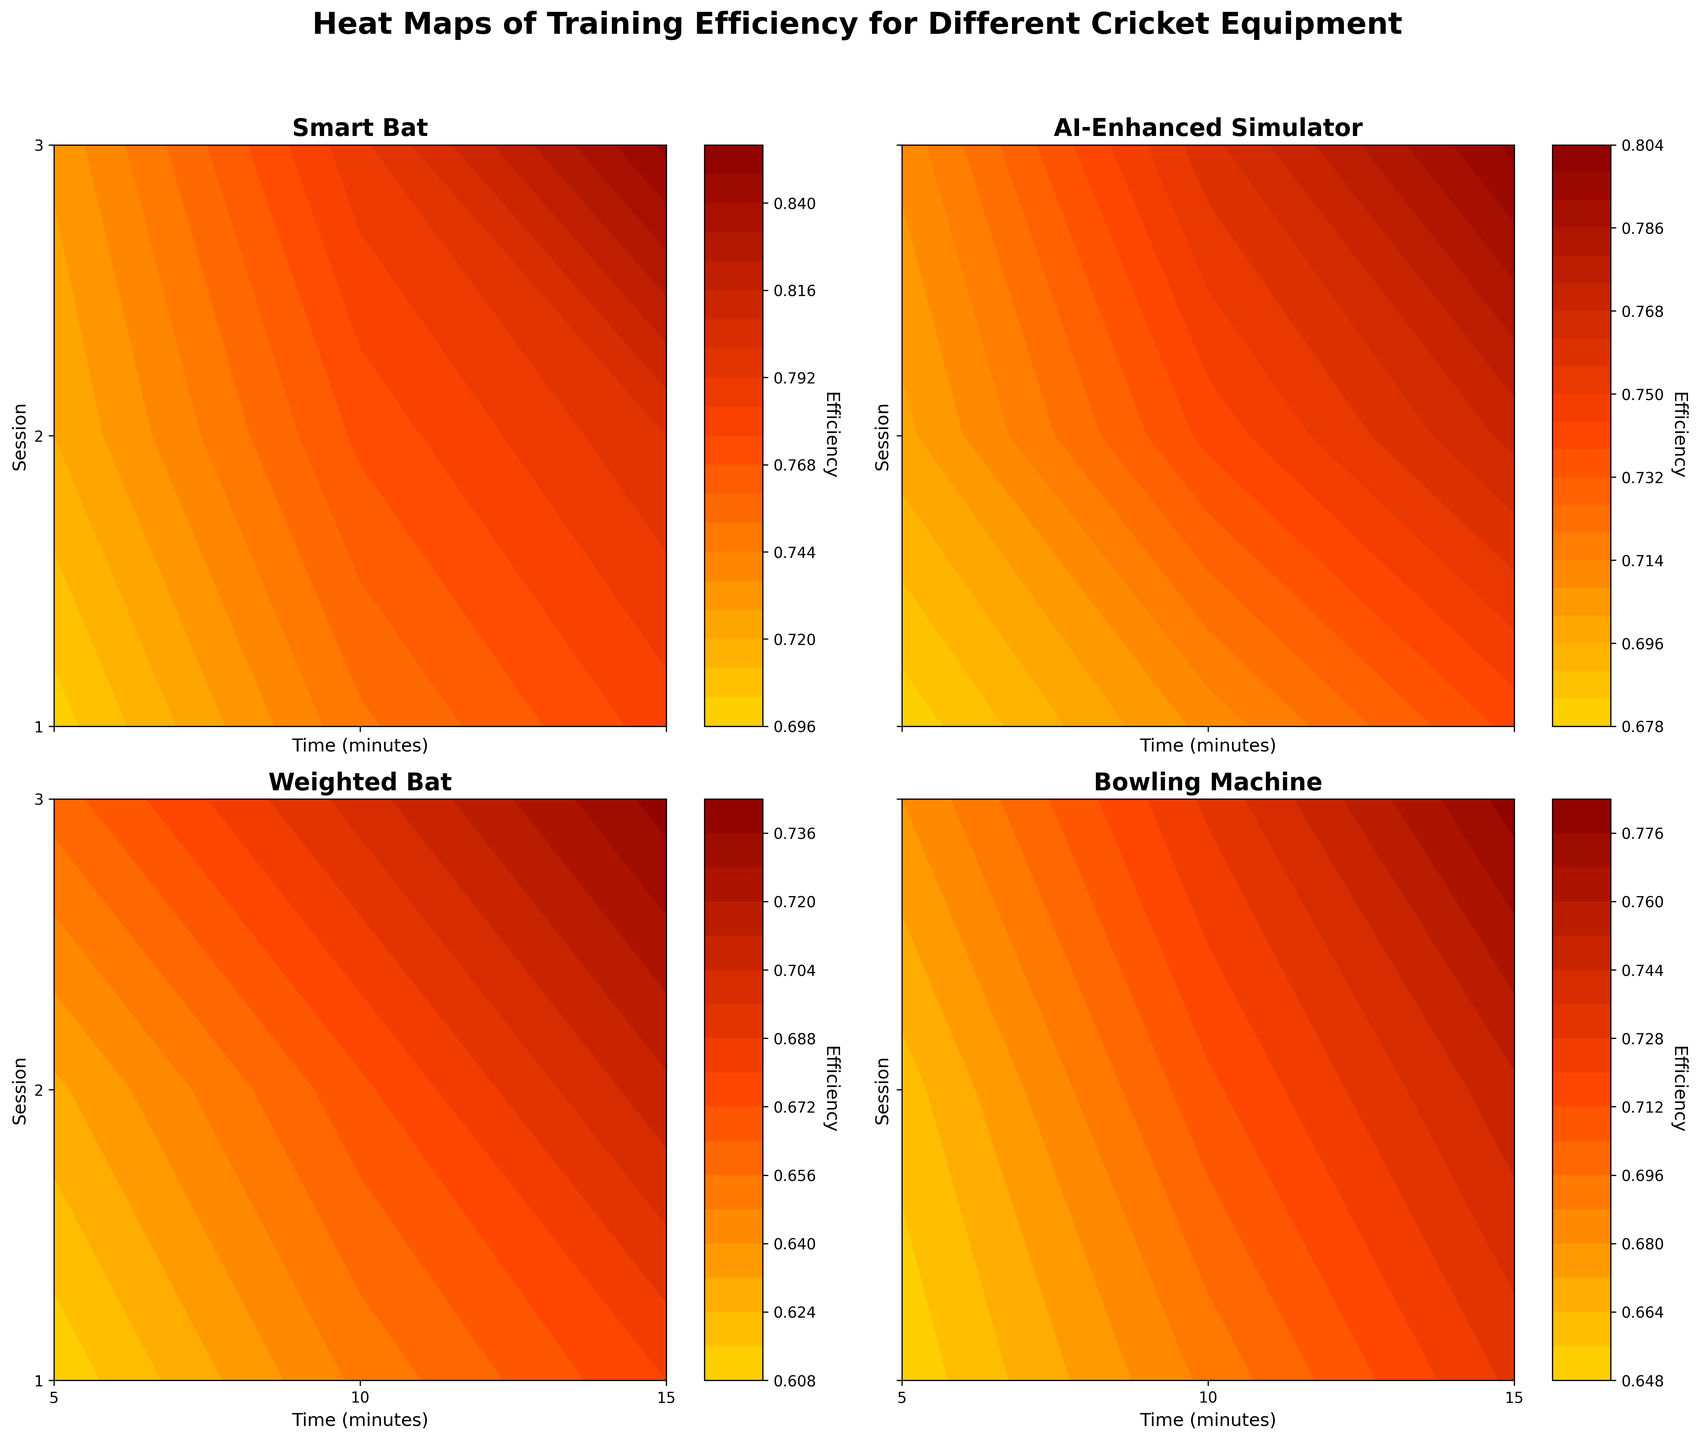What is the title of the figure? The figure's title is typically shown at the top of the plot. By looking at the rendered image, we can see the main title.
Answer: 'Heat Maps of Training Efficiency for Different Cricket Equipment' Which equipment appears to have the highest efficiency in the third training session? To determine this, we need to look at the contour plots for the third session across different equipment and see which has the darkest color (highest efficiency) in the third session. The darkest and most concentrated color areas indicate higher efficiency.
Answer: 'Smart Bat' What is the general trend of efficiency over time for the Bowling Machine? Observing the contour plot for the Bowling Machine from left to right (5 to 15 minutes), we see that the color gradually shifts to a darker tone as time increases, indicating that efficiency generally improves over time.
Answer: 'Efficiency increases over time' At 10 minutes, which equipment shows the lowest efficiency in the first session? By examining the contour plots for all equipment at the 10-minute mark during the first session, we compare the color intensity. The lighter the color, the lower the efficiency. Weighted Bat shows the lightest color at 10 minutes in the first session.
Answer: 'Weighted Bat' How does the efficiency progression compare between Smart Bat and AI-Enhanced Simulator in the second session? For a detailed comparison, look at the second session's contour plots for both Smart Bat and AI-Enhanced Simulator. Track the changes in color from 5 to 15 minutes. Both equipment show a progression to higher efficiency, but the Smart Bat achieves a darker color earlier than AI-Enhanced Simulator, indicating a potentially higher speed of improvement.
Answer: 'Smart Bat improves faster' What session and equipment combination exhibit the lowest overall efficiency? To find this, we need to look at all the contour plots and identify the lightest color presented. The contour plot for Weighted Bat in the first session around 5 minutes appears to have the lightest color, indicating the lowest efficiency.
Answer: 'Weighted Bat, Session 1' Does the Bowling Machine show consistent efficiency improvement across different sessions? Analyzing the plots for the Bowling Machine across the three sessions, we notice a consistent progression to darker colors (higher efficiency) from 5 to 15 minutes in each session, indicating improvement across all sessions.
Answer: 'Yes, it shows consistent improvement' Which equipment shows the most significant change in efficiency from 5 to 15 minutes in the third session? For this, we need to compare the contour plots of each equipment in the third session and observe the difference in color from 5 minutes to 15 minutes. Smart Bat shows the most significant color change, indicating a substantial increase in efficiency.
Answer: 'Smart Bat' What is the efficiency value for AI-Enhanced Simulator at 15 minutes in the second session? In the AI-Enhanced Simulator’s contour plot, locate the point at 15 minutes in the second session and check the color gradient’s corresponding efficiency value by referring to the color bar. The efficiency value for this combination is around 0.77.
Answer: '0.77' How do the heat maps for Weighted Bat and Bowling Machine compare in terms of overall efficiency trends? Comparing their contour plots, both Weighted Bat and Bowling Machine display progressive improvements in efficiency, with Bowling Machine showing a slightly darker overall color, indicating better efficiency gains over similar periods.
Answer: 'Bowling Machine shows slightly better overall efficiency trends' 